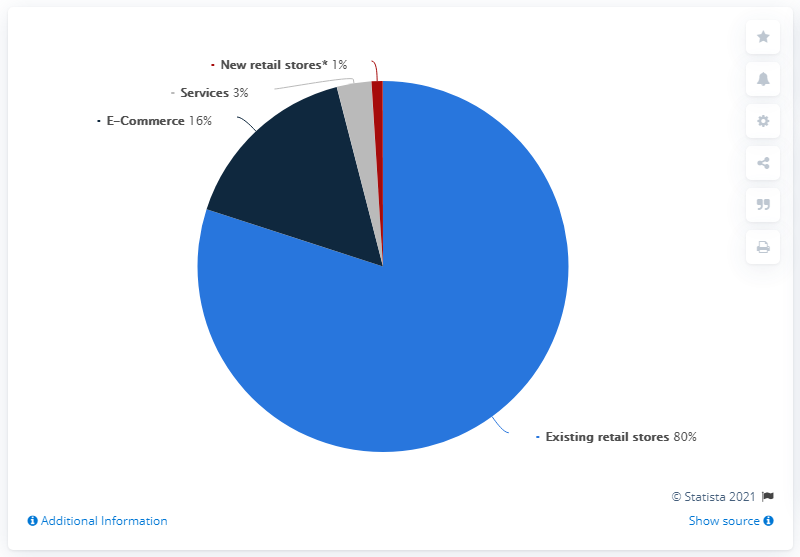Give some essential details in this illustration. The sum of e-commerce and services is 19. The pie chart shows that existing retail stores constitute more than 50% of the total category. 